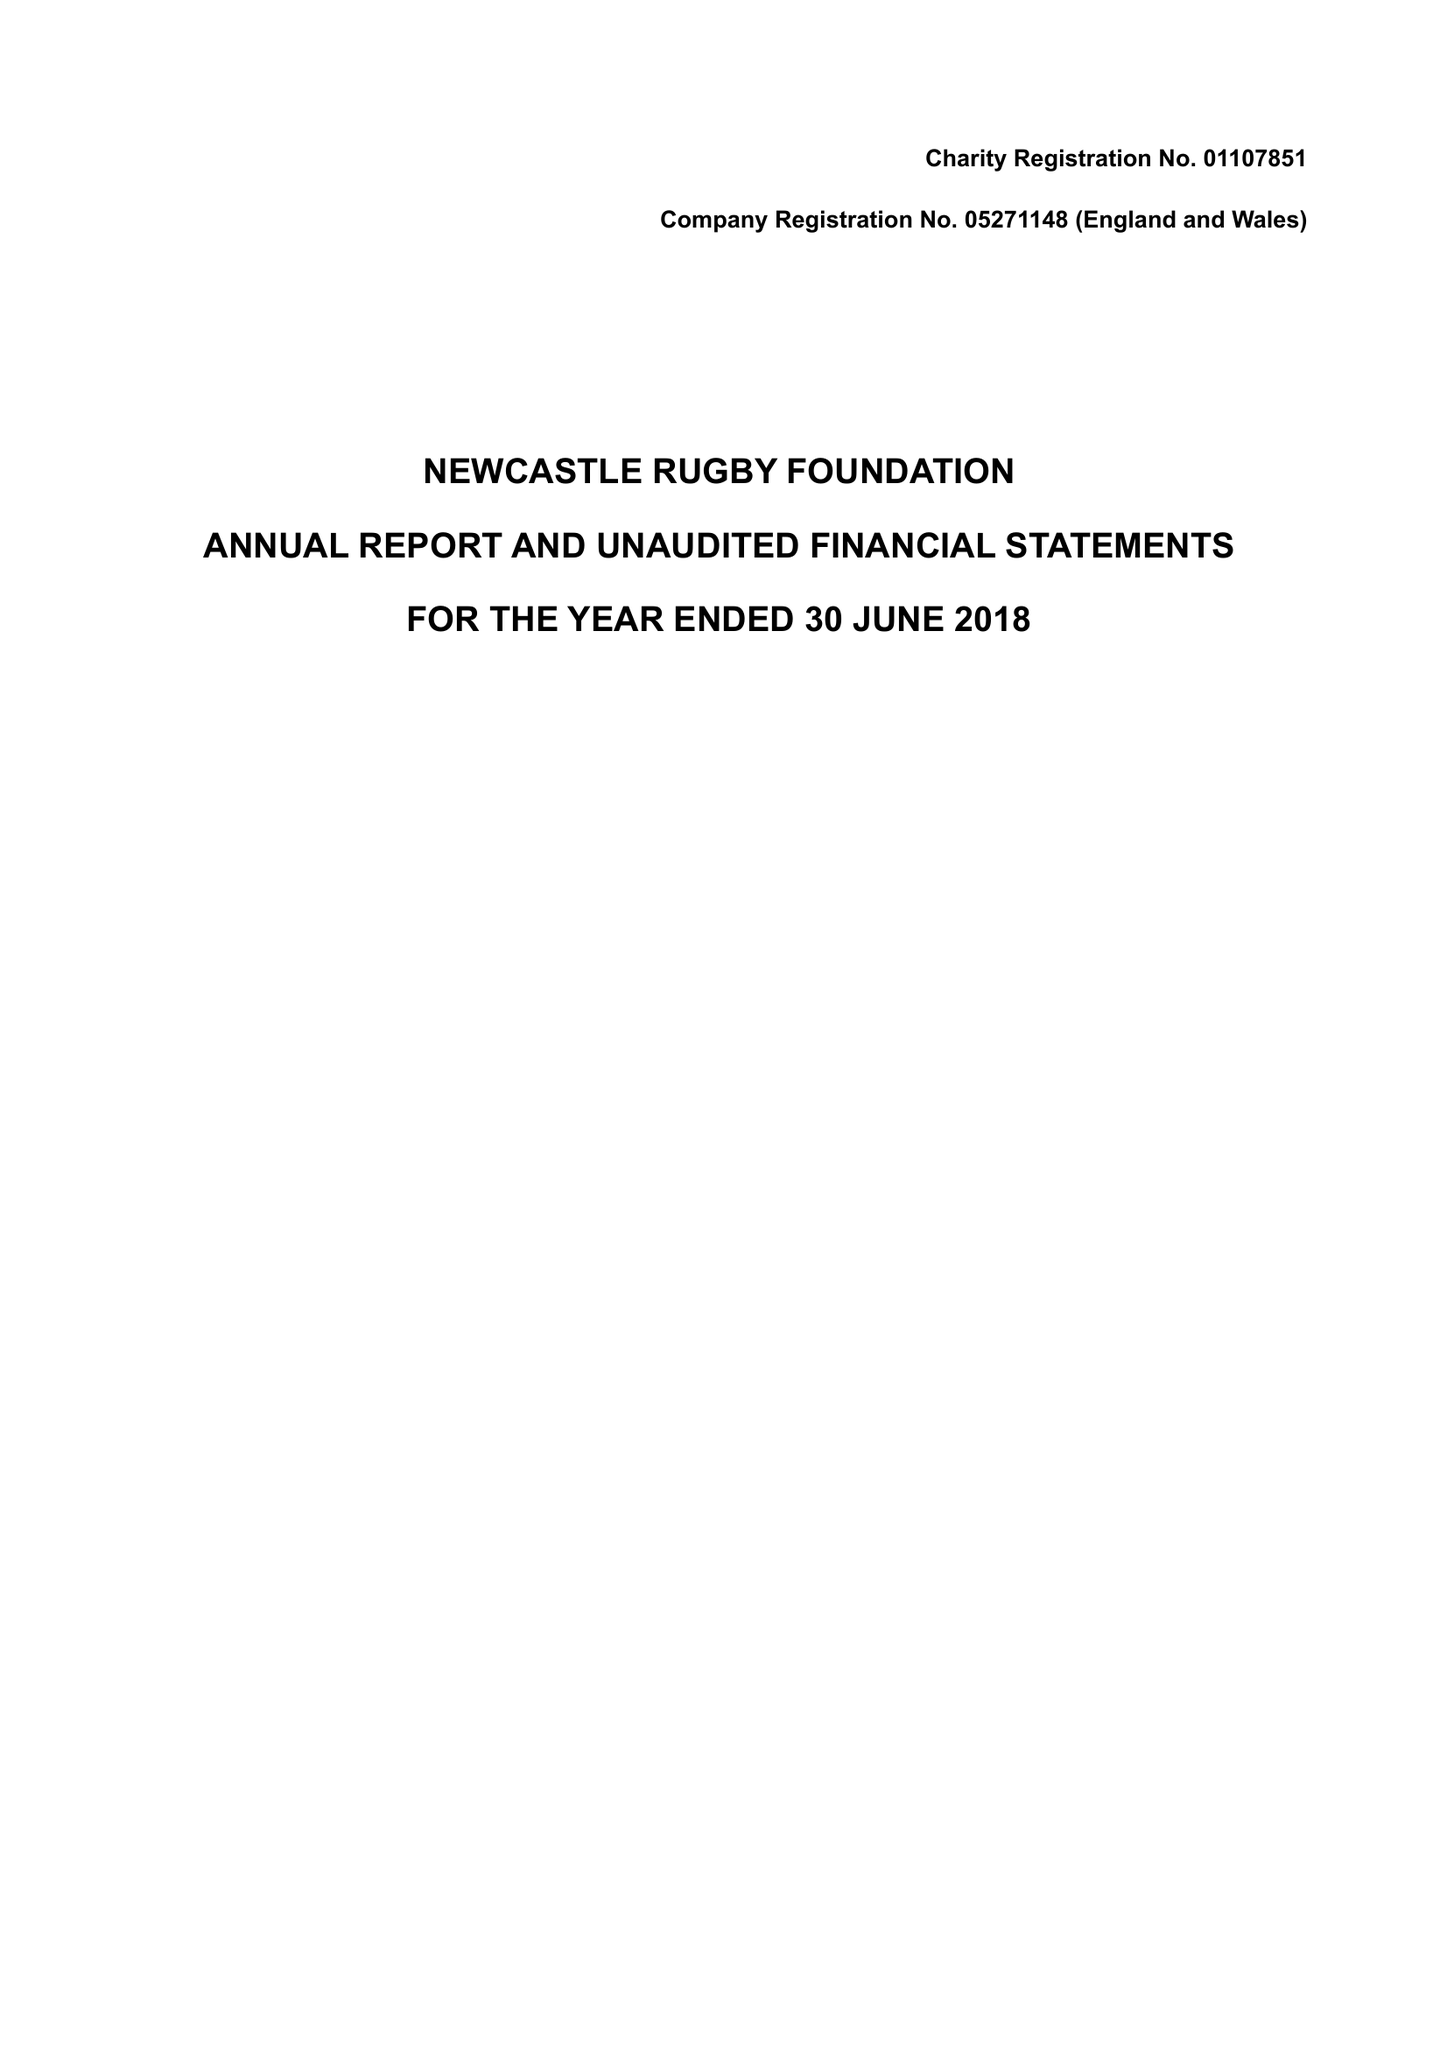What is the value for the charity_number?
Answer the question using a single word or phrase. 1107851 